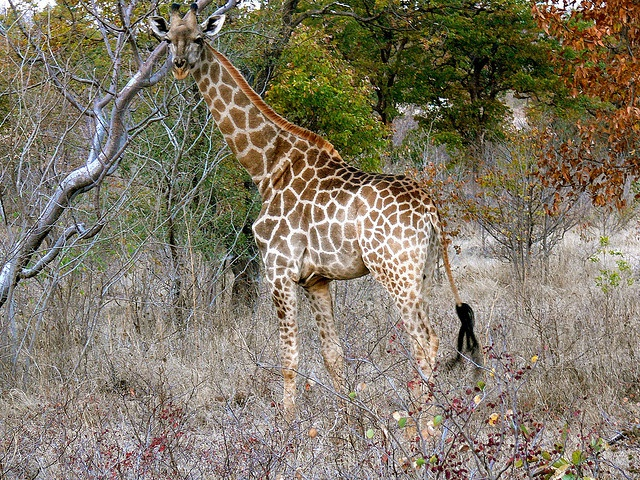Describe the objects in this image and their specific colors. I can see a giraffe in white, lightgray, darkgray, gray, and tan tones in this image. 